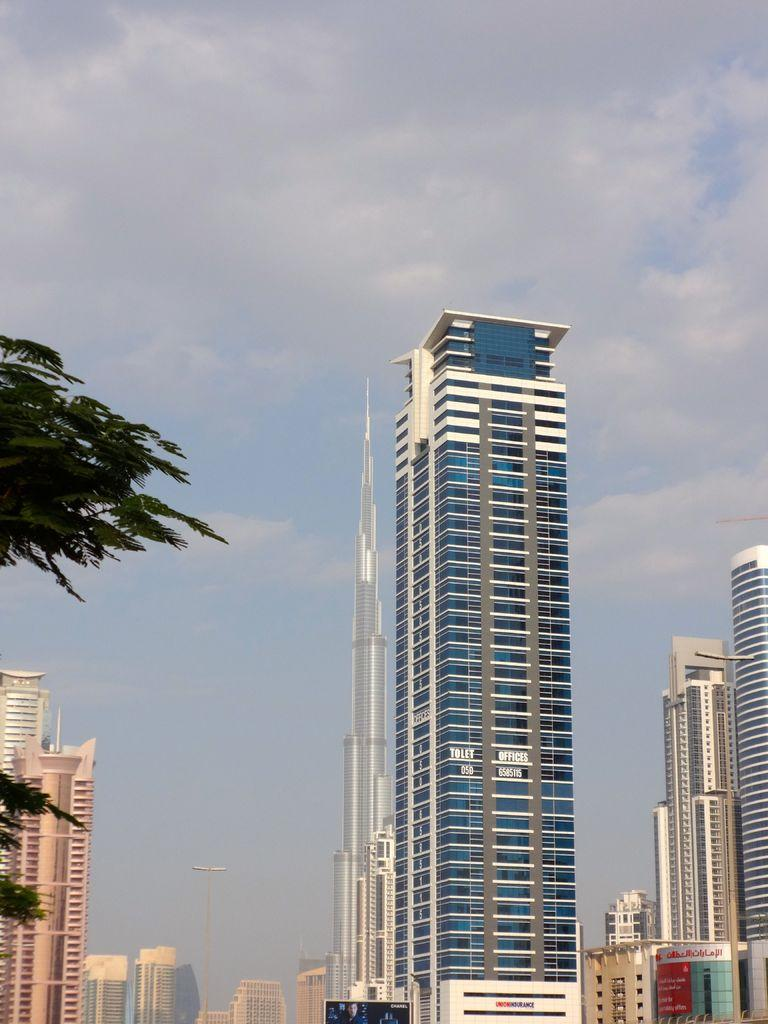What type of structures are present in the image? There are buildings and skyscrapers in the image. What else can be seen in the image besides the buildings and skyscrapers? There are poles and a tree on the left side of the image. What is visible at the top of the image? The sky is visible at the top of the image. How many jelly containers can be seen on the tree in the image? There are no jelly containers present in the image; it features a tree without any containers. What type of animal is hiding behind the skyscraper in the image? There are no animals visible in the image; it only features buildings, skyscrapers, poles, a tree, and the sky. 